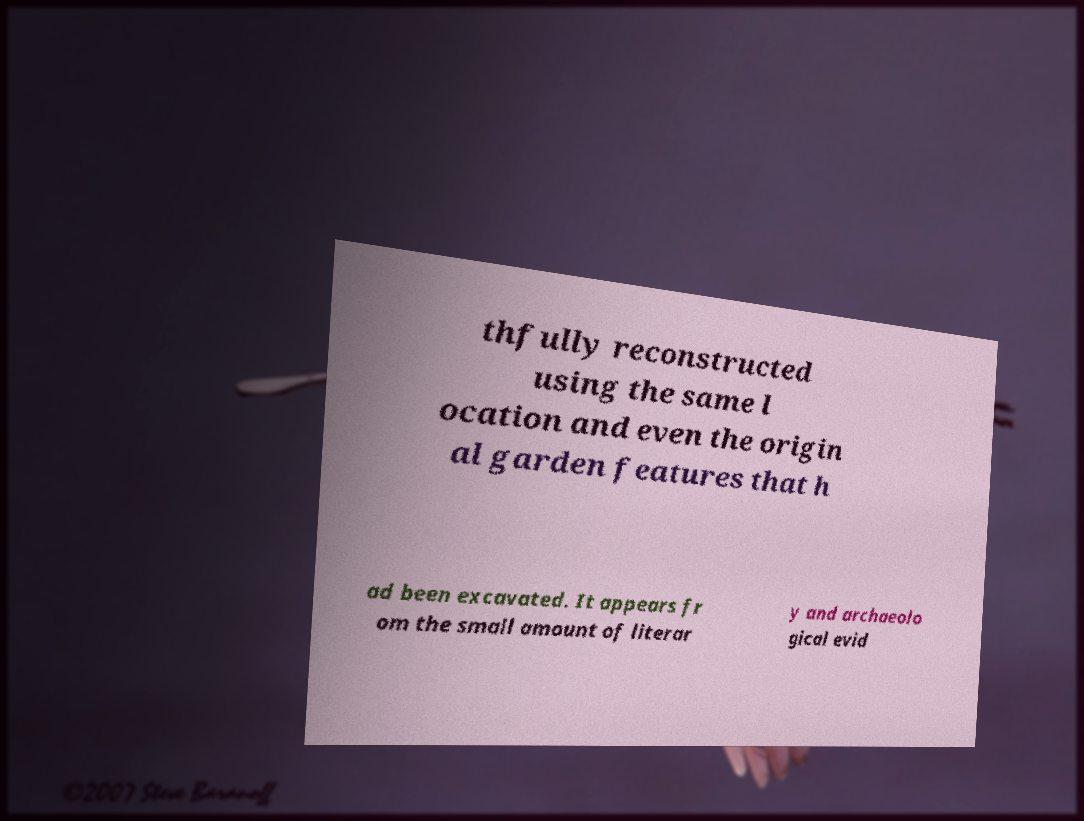Could you extract and type out the text from this image? thfully reconstructed using the same l ocation and even the origin al garden features that h ad been excavated. It appears fr om the small amount of literar y and archaeolo gical evid 